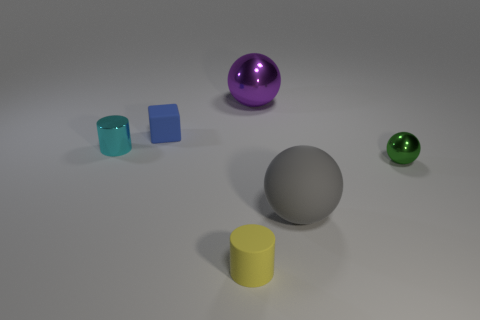Are the shadows consistent with a single light source? Yes, the shadows cast by the objects appear to be consistent with a single light source. The shadows are all oriented in the same direction and display a gradient that suggests they are all lit from the same angle. 